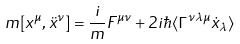<formula> <loc_0><loc_0><loc_500><loc_500>m [ x ^ { \mu } , \ddot { x } ^ { \nu } ] = { \frac { i } { m } } F ^ { \mu \nu } + 2 i \hbar { \langle } \Gamma ^ { \nu \lambda \mu } \dot { x } _ { \lambda } \rangle</formula> 